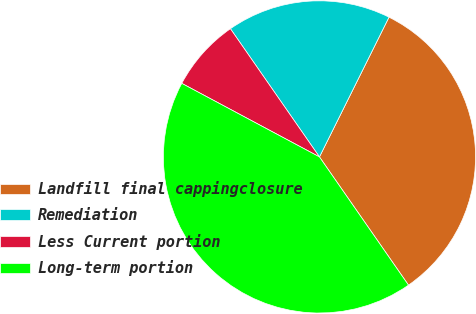<chart> <loc_0><loc_0><loc_500><loc_500><pie_chart><fcel>Landfill final cappingclosure<fcel>Remediation<fcel>Less Current portion<fcel>Long-term portion<nl><fcel>32.99%<fcel>17.01%<fcel>7.53%<fcel>42.47%<nl></chart> 